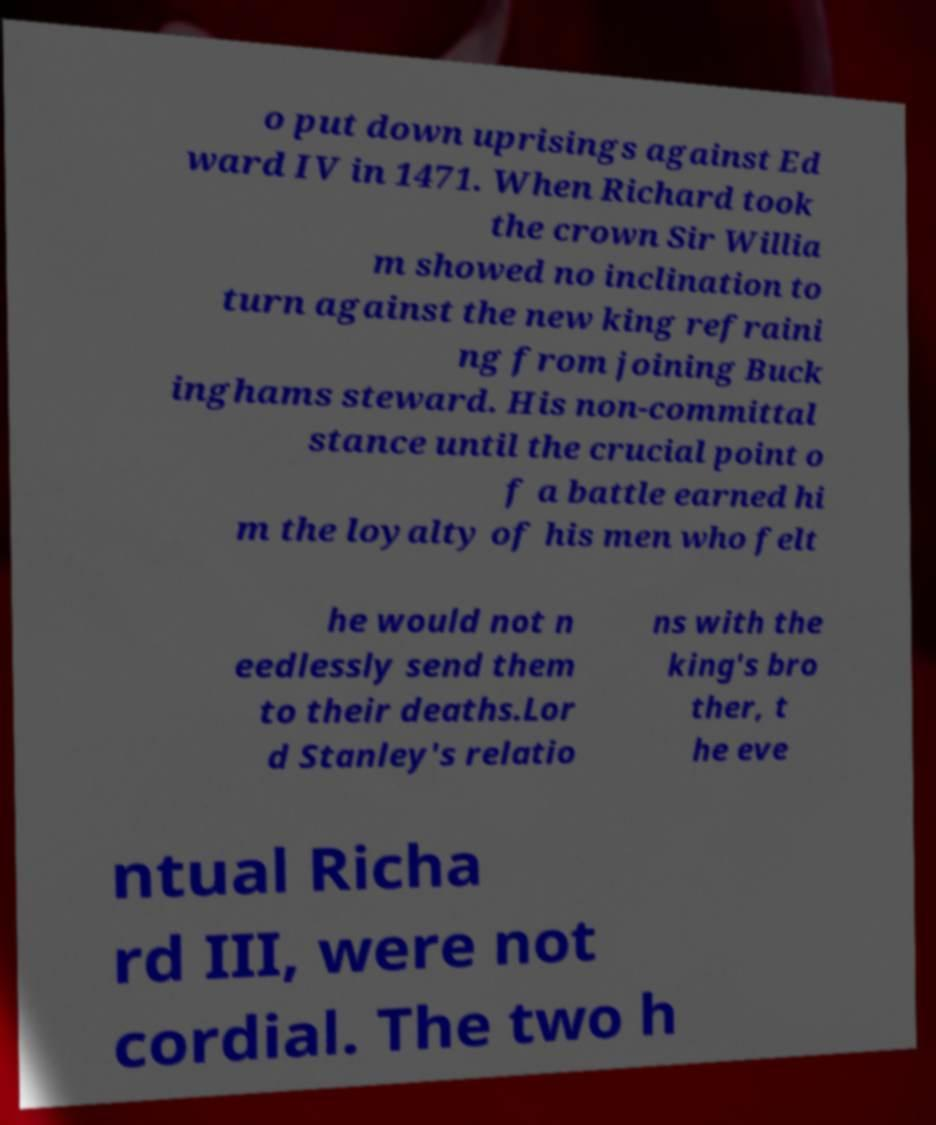For documentation purposes, I need the text within this image transcribed. Could you provide that? o put down uprisings against Ed ward IV in 1471. When Richard took the crown Sir Willia m showed no inclination to turn against the new king refraini ng from joining Buck inghams steward. His non-committal stance until the crucial point o f a battle earned hi m the loyalty of his men who felt he would not n eedlessly send them to their deaths.Lor d Stanley's relatio ns with the king's bro ther, t he eve ntual Richa rd III, were not cordial. The two h 